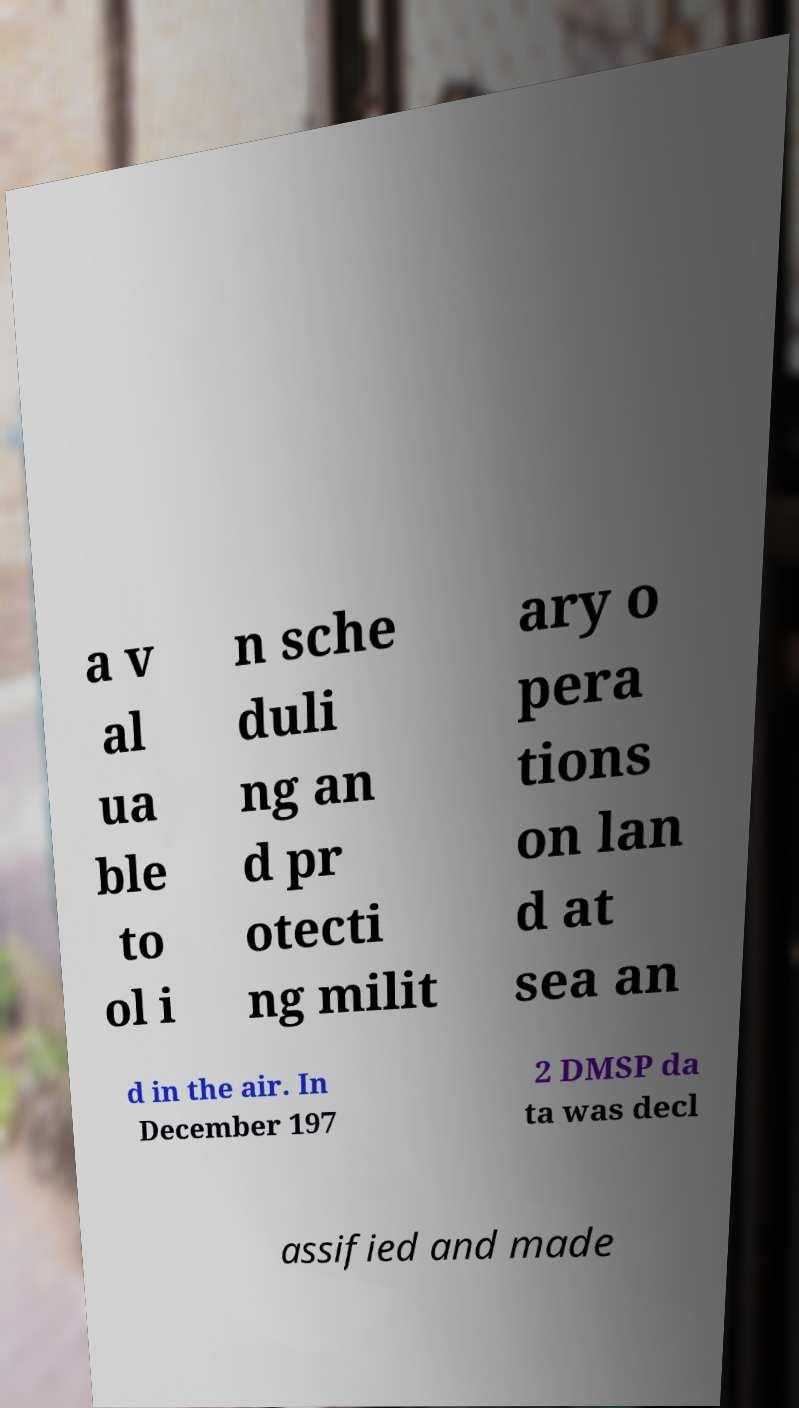Can you read and provide the text displayed in the image?This photo seems to have some interesting text. Can you extract and type it out for me? a v al ua ble to ol i n sche duli ng an d pr otecti ng milit ary o pera tions on lan d at sea an d in the air. In December 197 2 DMSP da ta was decl assified and made 